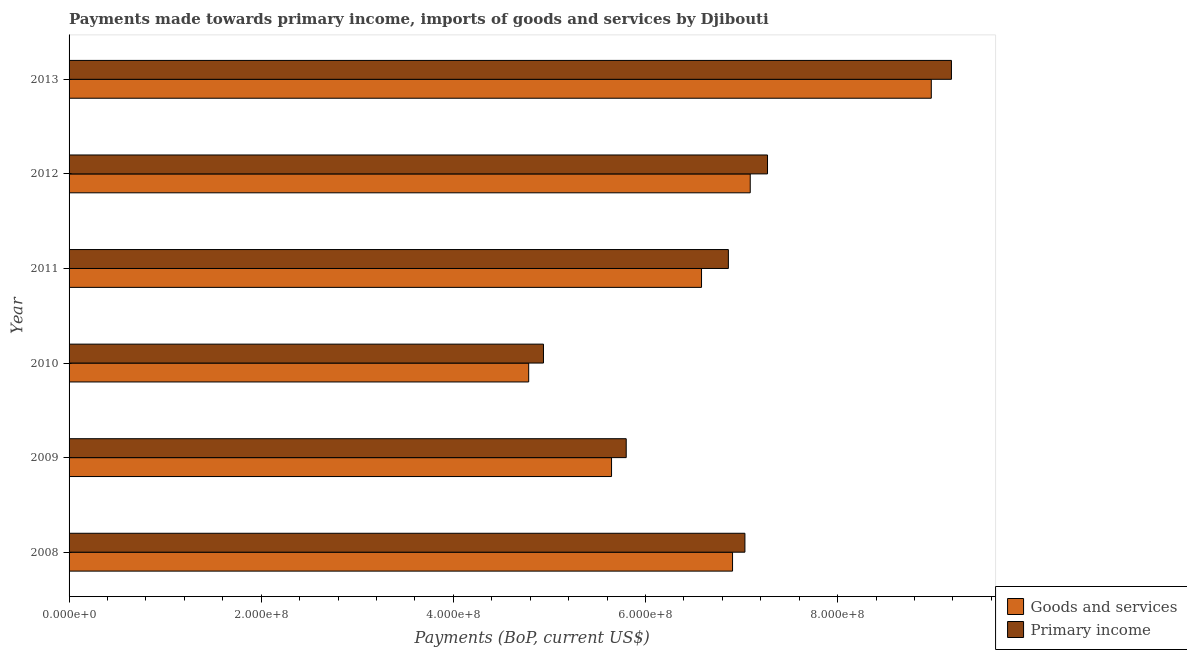How many different coloured bars are there?
Your response must be concise. 2. How many groups of bars are there?
Keep it short and to the point. 6. Are the number of bars per tick equal to the number of legend labels?
Provide a succinct answer. Yes. How many bars are there on the 1st tick from the top?
Give a very brief answer. 2. In how many cases, is the number of bars for a given year not equal to the number of legend labels?
Ensure brevity in your answer.  0. What is the payments made towards primary income in 2008?
Give a very brief answer. 7.04e+08. Across all years, what is the maximum payments made towards primary income?
Give a very brief answer. 9.18e+08. Across all years, what is the minimum payments made towards goods and services?
Ensure brevity in your answer.  4.78e+08. In which year was the payments made towards primary income maximum?
Provide a short and direct response. 2013. What is the total payments made towards primary income in the graph?
Give a very brief answer. 4.11e+09. What is the difference between the payments made towards goods and services in 2011 and that in 2013?
Keep it short and to the point. -2.39e+08. What is the difference between the payments made towards primary income in 2009 and the payments made towards goods and services in 2008?
Make the answer very short. -1.11e+08. What is the average payments made towards primary income per year?
Give a very brief answer. 6.85e+08. In the year 2013, what is the difference between the payments made towards primary income and payments made towards goods and services?
Keep it short and to the point. 2.10e+07. In how many years, is the payments made towards goods and services greater than 280000000 US$?
Make the answer very short. 6. What is the ratio of the payments made towards goods and services in 2011 to that in 2012?
Ensure brevity in your answer.  0.93. Is the payments made towards goods and services in 2008 less than that in 2012?
Provide a short and direct response. Yes. Is the difference between the payments made towards goods and services in 2011 and 2013 greater than the difference between the payments made towards primary income in 2011 and 2013?
Provide a short and direct response. No. What is the difference between the highest and the second highest payments made towards goods and services?
Your answer should be very brief. 1.88e+08. What is the difference between the highest and the lowest payments made towards primary income?
Your answer should be compact. 4.25e+08. In how many years, is the payments made towards primary income greater than the average payments made towards primary income taken over all years?
Ensure brevity in your answer.  4. Is the sum of the payments made towards goods and services in 2010 and 2012 greater than the maximum payments made towards primary income across all years?
Your response must be concise. Yes. What does the 2nd bar from the top in 2009 represents?
Provide a succinct answer. Goods and services. What does the 2nd bar from the bottom in 2013 represents?
Provide a short and direct response. Primary income. How many bars are there?
Offer a terse response. 12. Does the graph contain any zero values?
Offer a terse response. No. What is the title of the graph?
Keep it short and to the point. Payments made towards primary income, imports of goods and services by Djibouti. What is the label or title of the X-axis?
Keep it short and to the point. Payments (BoP, current US$). What is the Payments (BoP, current US$) in Goods and services in 2008?
Keep it short and to the point. 6.91e+08. What is the Payments (BoP, current US$) of Primary income in 2008?
Ensure brevity in your answer.  7.04e+08. What is the Payments (BoP, current US$) in Goods and services in 2009?
Offer a very short reply. 5.65e+08. What is the Payments (BoP, current US$) of Primary income in 2009?
Provide a succinct answer. 5.80e+08. What is the Payments (BoP, current US$) of Goods and services in 2010?
Make the answer very short. 4.78e+08. What is the Payments (BoP, current US$) of Primary income in 2010?
Your response must be concise. 4.94e+08. What is the Payments (BoP, current US$) of Goods and services in 2011?
Offer a very short reply. 6.58e+08. What is the Payments (BoP, current US$) in Primary income in 2011?
Keep it short and to the point. 6.86e+08. What is the Payments (BoP, current US$) of Goods and services in 2012?
Provide a succinct answer. 7.09e+08. What is the Payments (BoP, current US$) of Primary income in 2012?
Your response must be concise. 7.27e+08. What is the Payments (BoP, current US$) in Goods and services in 2013?
Your answer should be compact. 8.98e+08. What is the Payments (BoP, current US$) of Primary income in 2013?
Keep it short and to the point. 9.18e+08. Across all years, what is the maximum Payments (BoP, current US$) in Goods and services?
Your answer should be very brief. 8.98e+08. Across all years, what is the maximum Payments (BoP, current US$) of Primary income?
Ensure brevity in your answer.  9.18e+08. Across all years, what is the minimum Payments (BoP, current US$) of Goods and services?
Offer a very short reply. 4.78e+08. Across all years, what is the minimum Payments (BoP, current US$) of Primary income?
Your answer should be compact. 4.94e+08. What is the total Payments (BoP, current US$) of Goods and services in the graph?
Keep it short and to the point. 4.00e+09. What is the total Payments (BoP, current US$) of Primary income in the graph?
Your answer should be compact. 4.11e+09. What is the difference between the Payments (BoP, current US$) in Goods and services in 2008 and that in 2009?
Offer a terse response. 1.26e+08. What is the difference between the Payments (BoP, current US$) of Primary income in 2008 and that in 2009?
Provide a short and direct response. 1.24e+08. What is the difference between the Payments (BoP, current US$) of Goods and services in 2008 and that in 2010?
Give a very brief answer. 2.12e+08. What is the difference between the Payments (BoP, current US$) in Primary income in 2008 and that in 2010?
Your response must be concise. 2.10e+08. What is the difference between the Payments (BoP, current US$) in Goods and services in 2008 and that in 2011?
Provide a succinct answer. 3.23e+07. What is the difference between the Payments (BoP, current US$) of Primary income in 2008 and that in 2011?
Give a very brief answer. 1.72e+07. What is the difference between the Payments (BoP, current US$) of Goods and services in 2008 and that in 2012?
Offer a very short reply. -1.84e+07. What is the difference between the Payments (BoP, current US$) of Primary income in 2008 and that in 2012?
Your answer should be very brief. -2.35e+07. What is the difference between the Payments (BoP, current US$) in Goods and services in 2008 and that in 2013?
Offer a very short reply. -2.07e+08. What is the difference between the Payments (BoP, current US$) of Primary income in 2008 and that in 2013?
Ensure brevity in your answer.  -2.15e+08. What is the difference between the Payments (BoP, current US$) in Goods and services in 2009 and that in 2010?
Ensure brevity in your answer.  8.62e+07. What is the difference between the Payments (BoP, current US$) of Primary income in 2009 and that in 2010?
Provide a succinct answer. 8.61e+07. What is the difference between the Payments (BoP, current US$) of Goods and services in 2009 and that in 2011?
Your response must be concise. -9.37e+07. What is the difference between the Payments (BoP, current US$) in Primary income in 2009 and that in 2011?
Your answer should be compact. -1.06e+08. What is the difference between the Payments (BoP, current US$) of Goods and services in 2009 and that in 2012?
Keep it short and to the point. -1.44e+08. What is the difference between the Payments (BoP, current US$) in Primary income in 2009 and that in 2012?
Offer a terse response. -1.47e+08. What is the difference between the Payments (BoP, current US$) in Goods and services in 2009 and that in 2013?
Your answer should be very brief. -3.33e+08. What is the difference between the Payments (BoP, current US$) of Primary income in 2009 and that in 2013?
Offer a terse response. -3.39e+08. What is the difference between the Payments (BoP, current US$) in Goods and services in 2010 and that in 2011?
Provide a short and direct response. -1.80e+08. What is the difference between the Payments (BoP, current US$) in Primary income in 2010 and that in 2011?
Make the answer very short. -1.92e+08. What is the difference between the Payments (BoP, current US$) in Goods and services in 2010 and that in 2012?
Your answer should be compact. -2.31e+08. What is the difference between the Payments (BoP, current US$) of Primary income in 2010 and that in 2012?
Give a very brief answer. -2.33e+08. What is the difference between the Payments (BoP, current US$) of Goods and services in 2010 and that in 2013?
Ensure brevity in your answer.  -4.19e+08. What is the difference between the Payments (BoP, current US$) in Primary income in 2010 and that in 2013?
Your response must be concise. -4.25e+08. What is the difference between the Payments (BoP, current US$) in Goods and services in 2011 and that in 2012?
Ensure brevity in your answer.  -5.07e+07. What is the difference between the Payments (BoP, current US$) of Primary income in 2011 and that in 2012?
Keep it short and to the point. -4.07e+07. What is the difference between the Payments (BoP, current US$) of Goods and services in 2011 and that in 2013?
Provide a short and direct response. -2.39e+08. What is the difference between the Payments (BoP, current US$) of Primary income in 2011 and that in 2013?
Offer a terse response. -2.32e+08. What is the difference between the Payments (BoP, current US$) of Goods and services in 2012 and that in 2013?
Provide a short and direct response. -1.88e+08. What is the difference between the Payments (BoP, current US$) in Primary income in 2012 and that in 2013?
Your response must be concise. -1.91e+08. What is the difference between the Payments (BoP, current US$) of Goods and services in 2008 and the Payments (BoP, current US$) of Primary income in 2009?
Your answer should be compact. 1.11e+08. What is the difference between the Payments (BoP, current US$) in Goods and services in 2008 and the Payments (BoP, current US$) in Primary income in 2010?
Give a very brief answer. 1.97e+08. What is the difference between the Payments (BoP, current US$) in Goods and services in 2008 and the Payments (BoP, current US$) in Primary income in 2011?
Keep it short and to the point. 4.36e+06. What is the difference between the Payments (BoP, current US$) of Goods and services in 2008 and the Payments (BoP, current US$) of Primary income in 2012?
Your answer should be very brief. -3.64e+07. What is the difference between the Payments (BoP, current US$) in Goods and services in 2008 and the Payments (BoP, current US$) in Primary income in 2013?
Provide a short and direct response. -2.28e+08. What is the difference between the Payments (BoP, current US$) of Goods and services in 2009 and the Payments (BoP, current US$) of Primary income in 2010?
Your answer should be very brief. 7.09e+07. What is the difference between the Payments (BoP, current US$) of Goods and services in 2009 and the Payments (BoP, current US$) of Primary income in 2011?
Offer a very short reply. -1.22e+08. What is the difference between the Payments (BoP, current US$) of Goods and services in 2009 and the Payments (BoP, current US$) of Primary income in 2012?
Your answer should be compact. -1.62e+08. What is the difference between the Payments (BoP, current US$) of Goods and services in 2009 and the Payments (BoP, current US$) of Primary income in 2013?
Your answer should be compact. -3.54e+08. What is the difference between the Payments (BoP, current US$) of Goods and services in 2010 and the Payments (BoP, current US$) of Primary income in 2011?
Offer a terse response. -2.08e+08. What is the difference between the Payments (BoP, current US$) of Goods and services in 2010 and the Payments (BoP, current US$) of Primary income in 2012?
Offer a terse response. -2.49e+08. What is the difference between the Payments (BoP, current US$) in Goods and services in 2010 and the Payments (BoP, current US$) in Primary income in 2013?
Offer a terse response. -4.40e+08. What is the difference between the Payments (BoP, current US$) of Goods and services in 2011 and the Payments (BoP, current US$) of Primary income in 2012?
Ensure brevity in your answer.  -6.87e+07. What is the difference between the Payments (BoP, current US$) of Goods and services in 2011 and the Payments (BoP, current US$) of Primary income in 2013?
Provide a short and direct response. -2.60e+08. What is the difference between the Payments (BoP, current US$) in Goods and services in 2012 and the Payments (BoP, current US$) in Primary income in 2013?
Give a very brief answer. -2.09e+08. What is the average Payments (BoP, current US$) of Goods and services per year?
Offer a very short reply. 6.66e+08. What is the average Payments (BoP, current US$) in Primary income per year?
Offer a very short reply. 6.85e+08. In the year 2008, what is the difference between the Payments (BoP, current US$) of Goods and services and Payments (BoP, current US$) of Primary income?
Your answer should be very brief. -1.29e+07. In the year 2009, what is the difference between the Payments (BoP, current US$) in Goods and services and Payments (BoP, current US$) in Primary income?
Your answer should be compact. -1.53e+07. In the year 2010, what is the difference between the Payments (BoP, current US$) of Goods and services and Payments (BoP, current US$) of Primary income?
Offer a very short reply. -1.54e+07. In the year 2011, what is the difference between the Payments (BoP, current US$) in Goods and services and Payments (BoP, current US$) in Primary income?
Provide a short and direct response. -2.79e+07. In the year 2012, what is the difference between the Payments (BoP, current US$) in Goods and services and Payments (BoP, current US$) in Primary income?
Make the answer very short. -1.80e+07. In the year 2013, what is the difference between the Payments (BoP, current US$) in Goods and services and Payments (BoP, current US$) in Primary income?
Your response must be concise. -2.10e+07. What is the ratio of the Payments (BoP, current US$) of Goods and services in 2008 to that in 2009?
Provide a short and direct response. 1.22. What is the ratio of the Payments (BoP, current US$) in Primary income in 2008 to that in 2009?
Provide a succinct answer. 1.21. What is the ratio of the Payments (BoP, current US$) of Goods and services in 2008 to that in 2010?
Keep it short and to the point. 1.44. What is the ratio of the Payments (BoP, current US$) in Primary income in 2008 to that in 2010?
Ensure brevity in your answer.  1.42. What is the ratio of the Payments (BoP, current US$) of Goods and services in 2008 to that in 2011?
Your answer should be very brief. 1.05. What is the ratio of the Payments (BoP, current US$) of Primary income in 2008 to that in 2011?
Provide a succinct answer. 1.03. What is the ratio of the Payments (BoP, current US$) of Goods and services in 2008 to that in 2012?
Offer a terse response. 0.97. What is the ratio of the Payments (BoP, current US$) in Primary income in 2008 to that in 2012?
Give a very brief answer. 0.97. What is the ratio of the Payments (BoP, current US$) in Goods and services in 2008 to that in 2013?
Ensure brevity in your answer.  0.77. What is the ratio of the Payments (BoP, current US$) in Primary income in 2008 to that in 2013?
Provide a short and direct response. 0.77. What is the ratio of the Payments (BoP, current US$) of Goods and services in 2009 to that in 2010?
Make the answer very short. 1.18. What is the ratio of the Payments (BoP, current US$) of Primary income in 2009 to that in 2010?
Ensure brevity in your answer.  1.17. What is the ratio of the Payments (BoP, current US$) of Goods and services in 2009 to that in 2011?
Offer a terse response. 0.86. What is the ratio of the Payments (BoP, current US$) in Primary income in 2009 to that in 2011?
Make the answer very short. 0.85. What is the ratio of the Payments (BoP, current US$) in Goods and services in 2009 to that in 2012?
Offer a terse response. 0.8. What is the ratio of the Payments (BoP, current US$) in Primary income in 2009 to that in 2012?
Keep it short and to the point. 0.8. What is the ratio of the Payments (BoP, current US$) in Goods and services in 2009 to that in 2013?
Give a very brief answer. 0.63. What is the ratio of the Payments (BoP, current US$) in Primary income in 2009 to that in 2013?
Your answer should be very brief. 0.63. What is the ratio of the Payments (BoP, current US$) of Goods and services in 2010 to that in 2011?
Keep it short and to the point. 0.73. What is the ratio of the Payments (BoP, current US$) of Primary income in 2010 to that in 2011?
Give a very brief answer. 0.72. What is the ratio of the Payments (BoP, current US$) of Goods and services in 2010 to that in 2012?
Provide a succinct answer. 0.67. What is the ratio of the Payments (BoP, current US$) of Primary income in 2010 to that in 2012?
Ensure brevity in your answer.  0.68. What is the ratio of the Payments (BoP, current US$) of Goods and services in 2010 to that in 2013?
Offer a very short reply. 0.53. What is the ratio of the Payments (BoP, current US$) in Primary income in 2010 to that in 2013?
Make the answer very short. 0.54. What is the ratio of the Payments (BoP, current US$) in Goods and services in 2011 to that in 2012?
Make the answer very short. 0.93. What is the ratio of the Payments (BoP, current US$) in Primary income in 2011 to that in 2012?
Your answer should be compact. 0.94. What is the ratio of the Payments (BoP, current US$) of Goods and services in 2011 to that in 2013?
Your answer should be compact. 0.73. What is the ratio of the Payments (BoP, current US$) of Primary income in 2011 to that in 2013?
Give a very brief answer. 0.75. What is the ratio of the Payments (BoP, current US$) in Goods and services in 2012 to that in 2013?
Make the answer very short. 0.79. What is the ratio of the Payments (BoP, current US$) of Primary income in 2012 to that in 2013?
Offer a very short reply. 0.79. What is the difference between the highest and the second highest Payments (BoP, current US$) of Goods and services?
Give a very brief answer. 1.88e+08. What is the difference between the highest and the second highest Payments (BoP, current US$) of Primary income?
Your response must be concise. 1.91e+08. What is the difference between the highest and the lowest Payments (BoP, current US$) of Goods and services?
Ensure brevity in your answer.  4.19e+08. What is the difference between the highest and the lowest Payments (BoP, current US$) of Primary income?
Your response must be concise. 4.25e+08. 